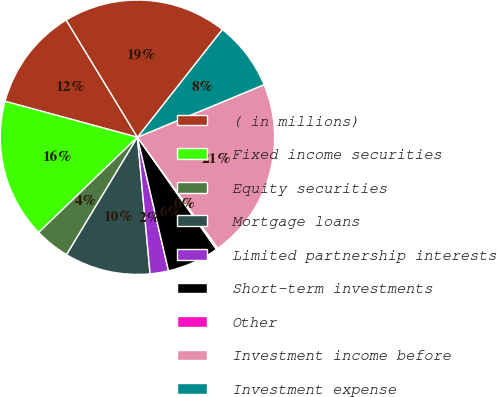Convert chart. <chart><loc_0><loc_0><loc_500><loc_500><pie_chart><fcel>( in millions)<fcel>Fixed income securities<fcel>Equity securities<fcel>Mortgage loans<fcel>Limited partnership interests<fcel>Short-term investments<fcel>Other<fcel>Investment income before<fcel>Investment expense<fcel>Net investment income<nl><fcel>12.09%<fcel>16.43%<fcel>4.15%<fcel>10.11%<fcel>2.17%<fcel>6.14%<fcel>0.19%<fcel>21.29%<fcel>8.12%<fcel>19.31%<nl></chart> 